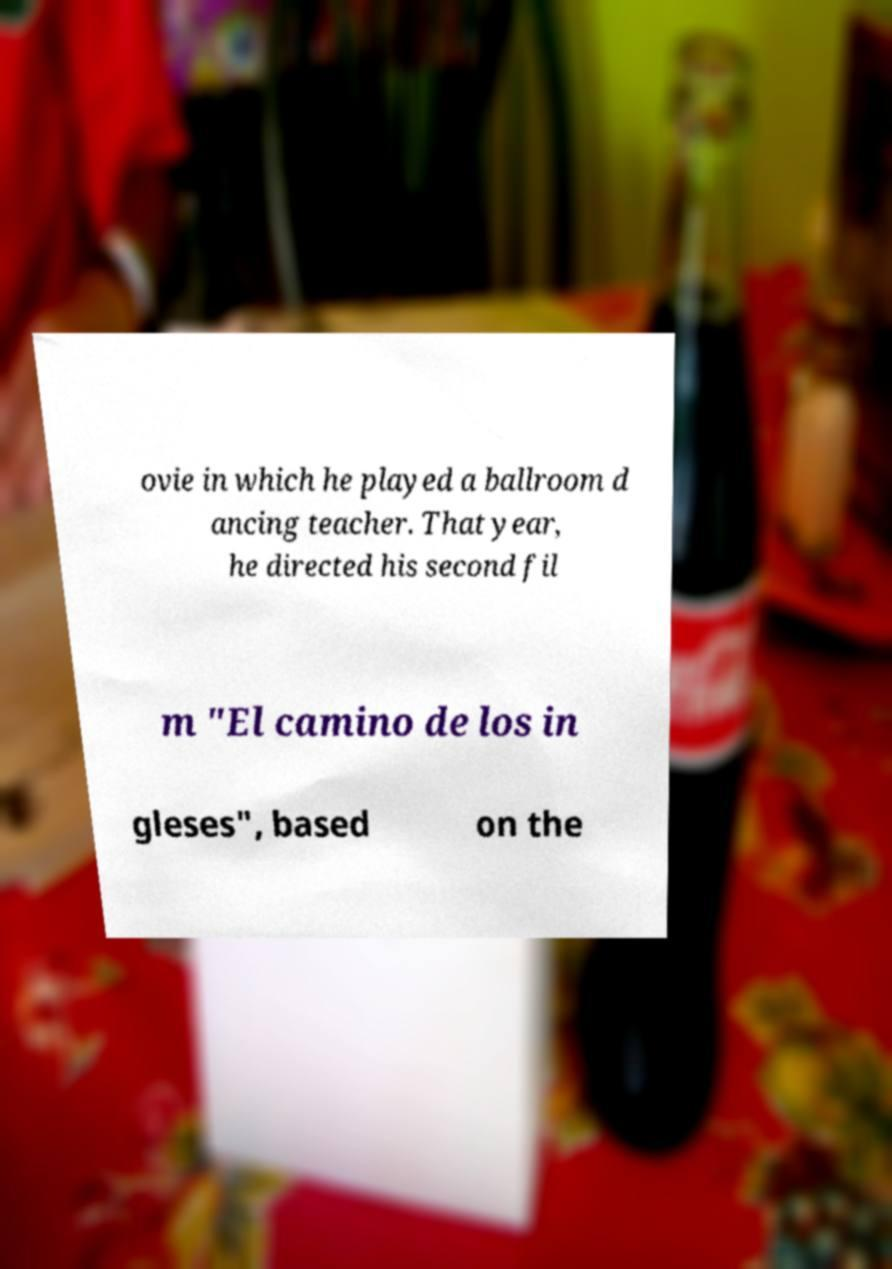Please read and relay the text visible in this image. What does it say? ovie in which he played a ballroom d ancing teacher. That year, he directed his second fil m "El camino de los in gleses", based on the 